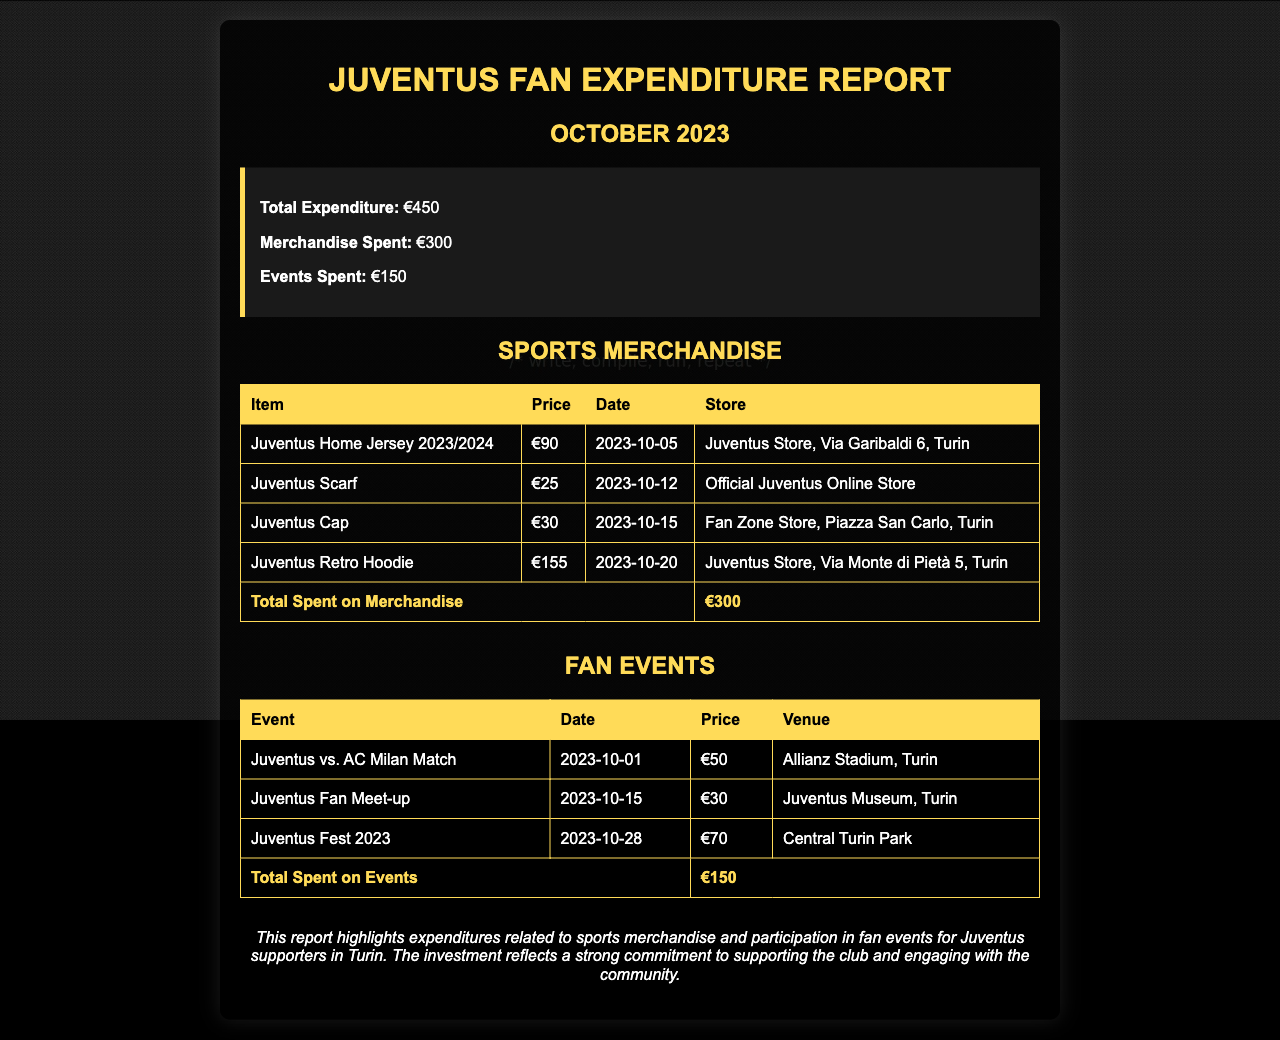what is the total expenditure? The total expenditure is listed in the summary of the report, which sums up all costs incurred by fans.
Answer: €450 how much was spent on merchandise? The report indicates the amount spent on sports merchandise in the summary section.
Answer: €300 when was the Juventus vs. AC Milan match? The date for this event is mentioned in the fan events table.
Answer: 2023-10-01 where was the Juventus Fest 2023 held? The venue for this event is noted in the fan events table.
Answer: Central Turin Park how much did the Juventus Retro Hoodie cost? The price of the Juventus Retro Hoodie is indicated in the sports merchandise table.
Answer: €155 what is the total spent on fan events? The total amount for fan events is shown in the summary and the relevant table.
Answer: €150 how many items were listed under sports merchandise? The total number of items can be counted from the sports merchandise table.
Answer: 4 which store sold the Juventus Scarf? The store where the Juventus Scarf was purchased is stated in the sports merchandise table.
Answer: Official Juventus Online Store what event occurred on 2023-10-15? The event on this date is listed in the fan events section.
Answer: Juventus Fan Meet-up 